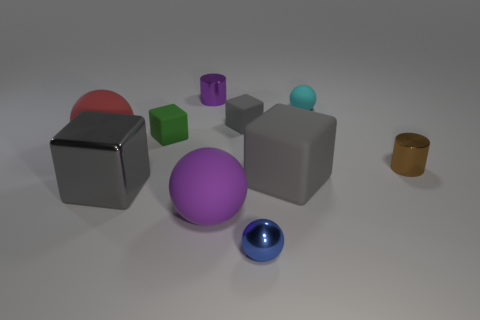How many gray cubes must be subtracted to get 1 gray cubes? 2 Subtract all cyan cylinders. How many gray cubes are left? 3 Subtract 1 spheres. How many spheres are left? 3 Subtract all cubes. How many objects are left? 6 Subtract 2 gray cubes. How many objects are left? 8 Subtract all tiny metallic objects. Subtract all tiny blue cylinders. How many objects are left? 7 Add 6 small shiny cylinders. How many small shiny cylinders are left? 8 Add 5 purple matte spheres. How many purple matte spheres exist? 6 